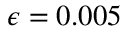Convert formula to latex. <formula><loc_0><loc_0><loc_500><loc_500>\epsilon = 0 . 0 0 5</formula> 